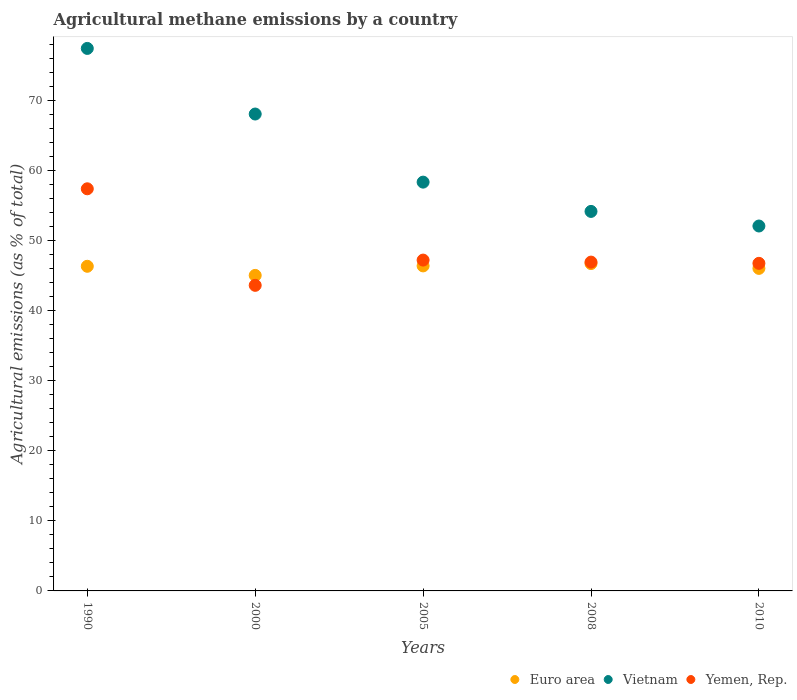Is the number of dotlines equal to the number of legend labels?
Your answer should be very brief. Yes. What is the amount of agricultural methane emitted in Yemen, Rep. in 2010?
Your answer should be very brief. 46.78. Across all years, what is the maximum amount of agricultural methane emitted in Euro area?
Your answer should be compact. 46.74. Across all years, what is the minimum amount of agricultural methane emitted in Yemen, Rep.?
Provide a short and direct response. 43.64. In which year was the amount of agricultural methane emitted in Vietnam maximum?
Your response must be concise. 1990. In which year was the amount of agricultural methane emitted in Yemen, Rep. minimum?
Make the answer very short. 2000. What is the total amount of agricultural methane emitted in Euro area in the graph?
Make the answer very short. 230.62. What is the difference between the amount of agricultural methane emitted in Vietnam in 2000 and that in 2005?
Your answer should be compact. 9.72. What is the difference between the amount of agricultural methane emitted in Euro area in 2000 and the amount of agricultural methane emitted in Vietnam in 2010?
Ensure brevity in your answer.  -7.05. What is the average amount of agricultural methane emitted in Yemen, Rep. per year?
Your answer should be compact. 48.41. In the year 2000, what is the difference between the amount of agricultural methane emitted in Euro area and amount of agricultural methane emitted in Vietnam?
Offer a terse response. -23.04. In how many years, is the amount of agricultural methane emitted in Euro area greater than 12 %?
Provide a succinct answer. 5. What is the ratio of the amount of agricultural methane emitted in Yemen, Rep. in 2000 to that in 2005?
Keep it short and to the point. 0.92. Is the amount of agricultural methane emitted in Yemen, Rep. in 2005 less than that in 2010?
Offer a very short reply. No. What is the difference between the highest and the second highest amount of agricultural methane emitted in Euro area?
Provide a short and direct response. 0.33. What is the difference between the highest and the lowest amount of agricultural methane emitted in Euro area?
Provide a succinct answer. 1.69. In how many years, is the amount of agricultural methane emitted in Vietnam greater than the average amount of agricultural methane emitted in Vietnam taken over all years?
Your answer should be compact. 2. Is the sum of the amount of agricultural methane emitted in Vietnam in 2000 and 2008 greater than the maximum amount of agricultural methane emitted in Yemen, Rep. across all years?
Offer a very short reply. Yes. Does the amount of agricultural methane emitted in Vietnam monotonically increase over the years?
Give a very brief answer. No. Is the amount of agricultural methane emitted in Yemen, Rep. strictly greater than the amount of agricultural methane emitted in Vietnam over the years?
Make the answer very short. No. Is the amount of agricultural methane emitted in Yemen, Rep. strictly less than the amount of agricultural methane emitted in Euro area over the years?
Provide a succinct answer. No. What is the difference between two consecutive major ticks on the Y-axis?
Your answer should be compact. 10. Does the graph contain grids?
Give a very brief answer. No. How are the legend labels stacked?
Make the answer very short. Horizontal. What is the title of the graph?
Give a very brief answer. Agricultural methane emissions by a country. Does "Spain" appear as one of the legend labels in the graph?
Your answer should be very brief. No. What is the label or title of the Y-axis?
Keep it short and to the point. Agricultural emissions (as % of total). What is the Agricultural emissions (as % of total) of Euro area in 1990?
Give a very brief answer. 46.36. What is the Agricultural emissions (as % of total) in Vietnam in 1990?
Your answer should be very brief. 77.47. What is the Agricultural emissions (as % of total) of Yemen, Rep. in 1990?
Your answer should be very brief. 57.42. What is the Agricultural emissions (as % of total) of Euro area in 2000?
Your response must be concise. 45.06. What is the Agricultural emissions (as % of total) of Vietnam in 2000?
Offer a terse response. 68.1. What is the Agricultural emissions (as % of total) of Yemen, Rep. in 2000?
Your answer should be compact. 43.64. What is the Agricultural emissions (as % of total) in Euro area in 2005?
Offer a very short reply. 46.41. What is the Agricultural emissions (as % of total) of Vietnam in 2005?
Provide a succinct answer. 58.37. What is the Agricultural emissions (as % of total) in Yemen, Rep. in 2005?
Offer a very short reply. 47.24. What is the Agricultural emissions (as % of total) in Euro area in 2008?
Provide a short and direct response. 46.74. What is the Agricultural emissions (as % of total) in Vietnam in 2008?
Your response must be concise. 54.19. What is the Agricultural emissions (as % of total) of Yemen, Rep. in 2008?
Give a very brief answer. 46.95. What is the Agricultural emissions (as % of total) in Euro area in 2010?
Keep it short and to the point. 46.06. What is the Agricultural emissions (as % of total) of Vietnam in 2010?
Keep it short and to the point. 52.11. What is the Agricultural emissions (as % of total) of Yemen, Rep. in 2010?
Provide a short and direct response. 46.78. Across all years, what is the maximum Agricultural emissions (as % of total) in Euro area?
Make the answer very short. 46.74. Across all years, what is the maximum Agricultural emissions (as % of total) of Vietnam?
Provide a succinct answer. 77.47. Across all years, what is the maximum Agricultural emissions (as % of total) of Yemen, Rep.?
Make the answer very short. 57.42. Across all years, what is the minimum Agricultural emissions (as % of total) of Euro area?
Offer a terse response. 45.06. Across all years, what is the minimum Agricultural emissions (as % of total) of Vietnam?
Your response must be concise. 52.11. Across all years, what is the minimum Agricultural emissions (as % of total) in Yemen, Rep.?
Offer a terse response. 43.64. What is the total Agricultural emissions (as % of total) in Euro area in the graph?
Your answer should be very brief. 230.62. What is the total Agricultural emissions (as % of total) in Vietnam in the graph?
Offer a terse response. 310.24. What is the total Agricultural emissions (as % of total) in Yemen, Rep. in the graph?
Ensure brevity in your answer.  242.03. What is the difference between the Agricultural emissions (as % of total) of Euro area in 1990 and that in 2000?
Provide a short and direct response. 1.3. What is the difference between the Agricultural emissions (as % of total) in Vietnam in 1990 and that in 2000?
Your response must be concise. 9.37. What is the difference between the Agricultural emissions (as % of total) of Yemen, Rep. in 1990 and that in 2000?
Ensure brevity in your answer.  13.79. What is the difference between the Agricultural emissions (as % of total) of Euro area in 1990 and that in 2005?
Your response must be concise. -0.05. What is the difference between the Agricultural emissions (as % of total) of Vietnam in 1990 and that in 2005?
Give a very brief answer. 19.09. What is the difference between the Agricultural emissions (as % of total) in Yemen, Rep. in 1990 and that in 2005?
Ensure brevity in your answer.  10.18. What is the difference between the Agricultural emissions (as % of total) of Euro area in 1990 and that in 2008?
Ensure brevity in your answer.  -0.39. What is the difference between the Agricultural emissions (as % of total) in Vietnam in 1990 and that in 2008?
Ensure brevity in your answer.  23.28. What is the difference between the Agricultural emissions (as % of total) in Yemen, Rep. in 1990 and that in 2008?
Make the answer very short. 10.47. What is the difference between the Agricultural emissions (as % of total) in Euro area in 1990 and that in 2010?
Provide a short and direct response. 0.3. What is the difference between the Agricultural emissions (as % of total) of Vietnam in 1990 and that in 2010?
Your response must be concise. 25.36. What is the difference between the Agricultural emissions (as % of total) of Yemen, Rep. in 1990 and that in 2010?
Offer a terse response. 10.64. What is the difference between the Agricultural emissions (as % of total) in Euro area in 2000 and that in 2005?
Offer a terse response. -1.36. What is the difference between the Agricultural emissions (as % of total) in Vietnam in 2000 and that in 2005?
Your answer should be very brief. 9.72. What is the difference between the Agricultural emissions (as % of total) of Yemen, Rep. in 2000 and that in 2005?
Offer a very short reply. -3.61. What is the difference between the Agricultural emissions (as % of total) of Euro area in 2000 and that in 2008?
Your response must be concise. -1.69. What is the difference between the Agricultural emissions (as % of total) of Vietnam in 2000 and that in 2008?
Offer a very short reply. 13.91. What is the difference between the Agricultural emissions (as % of total) of Yemen, Rep. in 2000 and that in 2008?
Your answer should be very brief. -3.32. What is the difference between the Agricultural emissions (as % of total) of Euro area in 2000 and that in 2010?
Your answer should be very brief. -1. What is the difference between the Agricultural emissions (as % of total) of Vietnam in 2000 and that in 2010?
Offer a terse response. 15.99. What is the difference between the Agricultural emissions (as % of total) in Yemen, Rep. in 2000 and that in 2010?
Your answer should be compact. -3.14. What is the difference between the Agricultural emissions (as % of total) in Euro area in 2005 and that in 2008?
Make the answer very short. -0.33. What is the difference between the Agricultural emissions (as % of total) of Vietnam in 2005 and that in 2008?
Your response must be concise. 4.18. What is the difference between the Agricultural emissions (as % of total) of Yemen, Rep. in 2005 and that in 2008?
Your answer should be compact. 0.29. What is the difference between the Agricultural emissions (as % of total) in Euro area in 2005 and that in 2010?
Offer a terse response. 0.36. What is the difference between the Agricultural emissions (as % of total) of Vietnam in 2005 and that in 2010?
Offer a very short reply. 6.27. What is the difference between the Agricultural emissions (as % of total) of Yemen, Rep. in 2005 and that in 2010?
Provide a succinct answer. 0.46. What is the difference between the Agricultural emissions (as % of total) in Euro area in 2008 and that in 2010?
Keep it short and to the point. 0.69. What is the difference between the Agricultural emissions (as % of total) of Vietnam in 2008 and that in 2010?
Offer a terse response. 2.08. What is the difference between the Agricultural emissions (as % of total) of Yemen, Rep. in 2008 and that in 2010?
Provide a succinct answer. 0.18. What is the difference between the Agricultural emissions (as % of total) of Euro area in 1990 and the Agricultural emissions (as % of total) of Vietnam in 2000?
Provide a succinct answer. -21.74. What is the difference between the Agricultural emissions (as % of total) in Euro area in 1990 and the Agricultural emissions (as % of total) in Yemen, Rep. in 2000?
Provide a short and direct response. 2.72. What is the difference between the Agricultural emissions (as % of total) in Vietnam in 1990 and the Agricultural emissions (as % of total) in Yemen, Rep. in 2000?
Provide a succinct answer. 33.83. What is the difference between the Agricultural emissions (as % of total) in Euro area in 1990 and the Agricultural emissions (as % of total) in Vietnam in 2005?
Your answer should be very brief. -12.02. What is the difference between the Agricultural emissions (as % of total) of Euro area in 1990 and the Agricultural emissions (as % of total) of Yemen, Rep. in 2005?
Your answer should be very brief. -0.88. What is the difference between the Agricultural emissions (as % of total) in Vietnam in 1990 and the Agricultural emissions (as % of total) in Yemen, Rep. in 2005?
Provide a succinct answer. 30.23. What is the difference between the Agricultural emissions (as % of total) in Euro area in 1990 and the Agricultural emissions (as % of total) in Vietnam in 2008?
Your answer should be very brief. -7.83. What is the difference between the Agricultural emissions (as % of total) of Euro area in 1990 and the Agricultural emissions (as % of total) of Yemen, Rep. in 2008?
Give a very brief answer. -0.6. What is the difference between the Agricultural emissions (as % of total) of Vietnam in 1990 and the Agricultural emissions (as % of total) of Yemen, Rep. in 2008?
Provide a short and direct response. 30.51. What is the difference between the Agricultural emissions (as % of total) in Euro area in 1990 and the Agricultural emissions (as % of total) in Vietnam in 2010?
Your answer should be compact. -5.75. What is the difference between the Agricultural emissions (as % of total) in Euro area in 1990 and the Agricultural emissions (as % of total) in Yemen, Rep. in 2010?
Give a very brief answer. -0.42. What is the difference between the Agricultural emissions (as % of total) in Vietnam in 1990 and the Agricultural emissions (as % of total) in Yemen, Rep. in 2010?
Offer a very short reply. 30.69. What is the difference between the Agricultural emissions (as % of total) of Euro area in 2000 and the Agricultural emissions (as % of total) of Vietnam in 2005?
Your response must be concise. -13.32. What is the difference between the Agricultural emissions (as % of total) of Euro area in 2000 and the Agricultural emissions (as % of total) of Yemen, Rep. in 2005?
Keep it short and to the point. -2.19. What is the difference between the Agricultural emissions (as % of total) in Vietnam in 2000 and the Agricultural emissions (as % of total) in Yemen, Rep. in 2005?
Your answer should be compact. 20.86. What is the difference between the Agricultural emissions (as % of total) of Euro area in 2000 and the Agricultural emissions (as % of total) of Vietnam in 2008?
Your answer should be compact. -9.14. What is the difference between the Agricultural emissions (as % of total) of Euro area in 2000 and the Agricultural emissions (as % of total) of Yemen, Rep. in 2008?
Your answer should be very brief. -1.9. What is the difference between the Agricultural emissions (as % of total) in Vietnam in 2000 and the Agricultural emissions (as % of total) in Yemen, Rep. in 2008?
Provide a short and direct response. 21.14. What is the difference between the Agricultural emissions (as % of total) in Euro area in 2000 and the Agricultural emissions (as % of total) in Vietnam in 2010?
Offer a very short reply. -7.05. What is the difference between the Agricultural emissions (as % of total) of Euro area in 2000 and the Agricultural emissions (as % of total) of Yemen, Rep. in 2010?
Provide a succinct answer. -1.72. What is the difference between the Agricultural emissions (as % of total) in Vietnam in 2000 and the Agricultural emissions (as % of total) in Yemen, Rep. in 2010?
Your response must be concise. 21.32. What is the difference between the Agricultural emissions (as % of total) in Euro area in 2005 and the Agricultural emissions (as % of total) in Vietnam in 2008?
Provide a short and direct response. -7.78. What is the difference between the Agricultural emissions (as % of total) of Euro area in 2005 and the Agricultural emissions (as % of total) of Yemen, Rep. in 2008?
Keep it short and to the point. -0.54. What is the difference between the Agricultural emissions (as % of total) of Vietnam in 2005 and the Agricultural emissions (as % of total) of Yemen, Rep. in 2008?
Your answer should be compact. 11.42. What is the difference between the Agricultural emissions (as % of total) of Euro area in 2005 and the Agricultural emissions (as % of total) of Vietnam in 2010?
Offer a very short reply. -5.7. What is the difference between the Agricultural emissions (as % of total) in Euro area in 2005 and the Agricultural emissions (as % of total) in Yemen, Rep. in 2010?
Your answer should be compact. -0.37. What is the difference between the Agricultural emissions (as % of total) of Vietnam in 2005 and the Agricultural emissions (as % of total) of Yemen, Rep. in 2010?
Make the answer very short. 11.6. What is the difference between the Agricultural emissions (as % of total) of Euro area in 2008 and the Agricultural emissions (as % of total) of Vietnam in 2010?
Give a very brief answer. -5.37. What is the difference between the Agricultural emissions (as % of total) in Euro area in 2008 and the Agricultural emissions (as % of total) in Yemen, Rep. in 2010?
Give a very brief answer. -0.04. What is the difference between the Agricultural emissions (as % of total) of Vietnam in 2008 and the Agricultural emissions (as % of total) of Yemen, Rep. in 2010?
Offer a very short reply. 7.41. What is the average Agricultural emissions (as % of total) in Euro area per year?
Keep it short and to the point. 46.12. What is the average Agricultural emissions (as % of total) of Vietnam per year?
Your answer should be compact. 62.05. What is the average Agricultural emissions (as % of total) of Yemen, Rep. per year?
Offer a terse response. 48.41. In the year 1990, what is the difference between the Agricultural emissions (as % of total) in Euro area and Agricultural emissions (as % of total) in Vietnam?
Your answer should be compact. -31.11. In the year 1990, what is the difference between the Agricultural emissions (as % of total) in Euro area and Agricultural emissions (as % of total) in Yemen, Rep.?
Offer a terse response. -11.06. In the year 1990, what is the difference between the Agricultural emissions (as % of total) in Vietnam and Agricultural emissions (as % of total) in Yemen, Rep.?
Your answer should be compact. 20.04. In the year 2000, what is the difference between the Agricultural emissions (as % of total) in Euro area and Agricultural emissions (as % of total) in Vietnam?
Your answer should be compact. -23.04. In the year 2000, what is the difference between the Agricultural emissions (as % of total) of Euro area and Agricultural emissions (as % of total) of Yemen, Rep.?
Keep it short and to the point. 1.42. In the year 2000, what is the difference between the Agricultural emissions (as % of total) of Vietnam and Agricultural emissions (as % of total) of Yemen, Rep.?
Give a very brief answer. 24.46. In the year 2005, what is the difference between the Agricultural emissions (as % of total) in Euro area and Agricultural emissions (as % of total) in Vietnam?
Keep it short and to the point. -11.96. In the year 2005, what is the difference between the Agricultural emissions (as % of total) of Euro area and Agricultural emissions (as % of total) of Yemen, Rep.?
Your answer should be compact. -0.83. In the year 2005, what is the difference between the Agricultural emissions (as % of total) in Vietnam and Agricultural emissions (as % of total) in Yemen, Rep.?
Provide a succinct answer. 11.13. In the year 2008, what is the difference between the Agricultural emissions (as % of total) in Euro area and Agricultural emissions (as % of total) in Vietnam?
Provide a succinct answer. -7.45. In the year 2008, what is the difference between the Agricultural emissions (as % of total) of Euro area and Agricultural emissions (as % of total) of Yemen, Rep.?
Your response must be concise. -0.21. In the year 2008, what is the difference between the Agricultural emissions (as % of total) of Vietnam and Agricultural emissions (as % of total) of Yemen, Rep.?
Give a very brief answer. 7.24. In the year 2010, what is the difference between the Agricultural emissions (as % of total) in Euro area and Agricultural emissions (as % of total) in Vietnam?
Provide a short and direct response. -6.05. In the year 2010, what is the difference between the Agricultural emissions (as % of total) in Euro area and Agricultural emissions (as % of total) in Yemen, Rep.?
Your answer should be compact. -0.72. In the year 2010, what is the difference between the Agricultural emissions (as % of total) of Vietnam and Agricultural emissions (as % of total) of Yemen, Rep.?
Provide a succinct answer. 5.33. What is the ratio of the Agricultural emissions (as % of total) in Euro area in 1990 to that in 2000?
Offer a very short reply. 1.03. What is the ratio of the Agricultural emissions (as % of total) of Vietnam in 1990 to that in 2000?
Provide a short and direct response. 1.14. What is the ratio of the Agricultural emissions (as % of total) of Yemen, Rep. in 1990 to that in 2000?
Provide a short and direct response. 1.32. What is the ratio of the Agricultural emissions (as % of total) of Vietnam in 1990 to that in 2005?
Ensure brevity in your answer.  1.33. What is the ratio of the Agricultural emissions (as % of total) of Yemen, Rep. in 1990 to that in 2005?
Your answer should be very brief. 1.22. What is the ratio of the Agricultural emissions (as % of total) in Vietnam in 1990 to that in 2008?
Your answer should be very brief. 1.43. What is the ratio of the Agricultural emissions (as % of total) in Yemen, Rep. in 1990 to that in 2008?
Keep it short and to the point. 1.22. What is the ratio of the Agricultural emissions (as % of total) in Vietnam in 1990 to that in 2010?
Provide a short and direct response. 1.49. What is the ratio of the Agricultural emissions (as % of total) of Yemen, Rep. in 1990 to that in 2010?
Provide a succinct answer. 1.23. What is the ratio of the Agricultural emissions (as % of total) in Euro area in 2000 to that in 2005?
Provide a short and direct response. 0.97. What is the ratio of the Agricultural emissions (as % of total) in Vietnam in 2000 to that in 2005?
Provide a short and direct response. 1.17. What is the ratio of the Agricultural emissions (as % of total) of Yemen, Rep. in 2000 to that in 2005?
Offer a terse response. 0.92. What is the ratio of the Agricultural emissions (as % of total) in Euro area in 2000 to that in 2008?
Make the answer very short. 0.96. What is the ratio of the Agricultural emissions (as % of total) of Vietnam in 2000 to that in 2008?
Offer a terse response. 1.26. What is the ratio of the Agricultural emissions (as % of total) of Yemen, Rep. in 2000 to that in 2008?
Offer a terse response. 0.93. What is the ratio of the Agricultural emissions (as % of total) in Euro area in 2000 to that in 2010?
Your response must be concise. 0.98. What is the ratio of the Agricultural emissions (as % of total) in Vietnam in 2000 to that in 2010?
Give a very brief answer. 1.31. What is the ratio of the Agricultural emissions (as % of total) in Yemen, Rep. in 2000 to that in 2010?
Your answer should be very brief. 0.93. What is the ratio of the Agricultural emissions (as % of total) in Vietnam in 2005 to that in 2008?
Provide a succinct answer. 1.08. What is the ratio of the Agricultural emissions (as % of total) of Yemen, Rep. in 2005 to that in 2008?
Keep it short and to the point. 1.01. What is the ratio of the Agricultural emissions (as % of total) in Euro area in 2005 to that in 2010?
Provide a short and direct response. 1.01. What is the ratio of the Agricultural emissions (as % of total) in Vietnam in 2005 to that in 2010?
Provide a short and direct response. 1.12. What is the ratio of the Agricultural emissions (as % of total) in Yemen, Rep. in 2005 to that in 2010?
Offer a terse response. 1.01. What is the ratio of the Agricultural emissions (as % of total) in Euro area in 2008 to that in 2010?
Your response must be concise. 1.01. What is the ratio of the Agricultural emissions (as % of total) of Yemen, Rep. in 2008 to that in 2010?
Provide a succinct answer. 1. What is the difference between the highest and the second highest Agricultural emissions (as % of total) in Euro area?
Provide a short and direct response. 0.33. What is the difference between the highest and the second highest Agricultural emissions (as % of total) in Vietnam?
Your response must be concise. 9.37. What is the difference between the highest and the second highest Agricultural emissions (as % of total) in Yemen, Rep.?
Provide a short and direct response. 10.18. What is the difference between the highest and the lowest Agricultural emissions (as % of total) in Euro area?
Offer a terse response. 1.69. What is the difference between the highest and the lowest Agricultural emissions (as % of total) in Vietnam?
Provide a succinct answer. 25.36. What is the difference between the highest and the lowest Agricultural emissions (as % of total) in Yemen, Rep.?
Your answer should be compact. 13.79. 